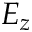<formula> <loc_0><loc_0><loc_500><loc_500>E _ { z }</formula> 